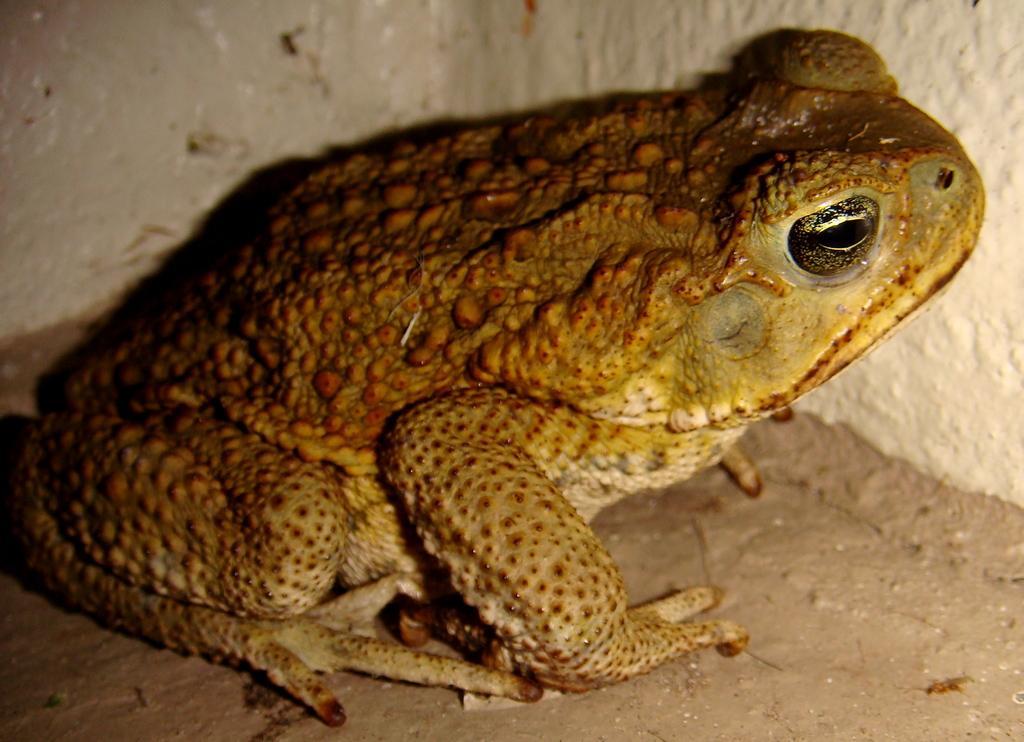Can you describe this image briefly? There is a brown color frog. In the back there is a wall. 